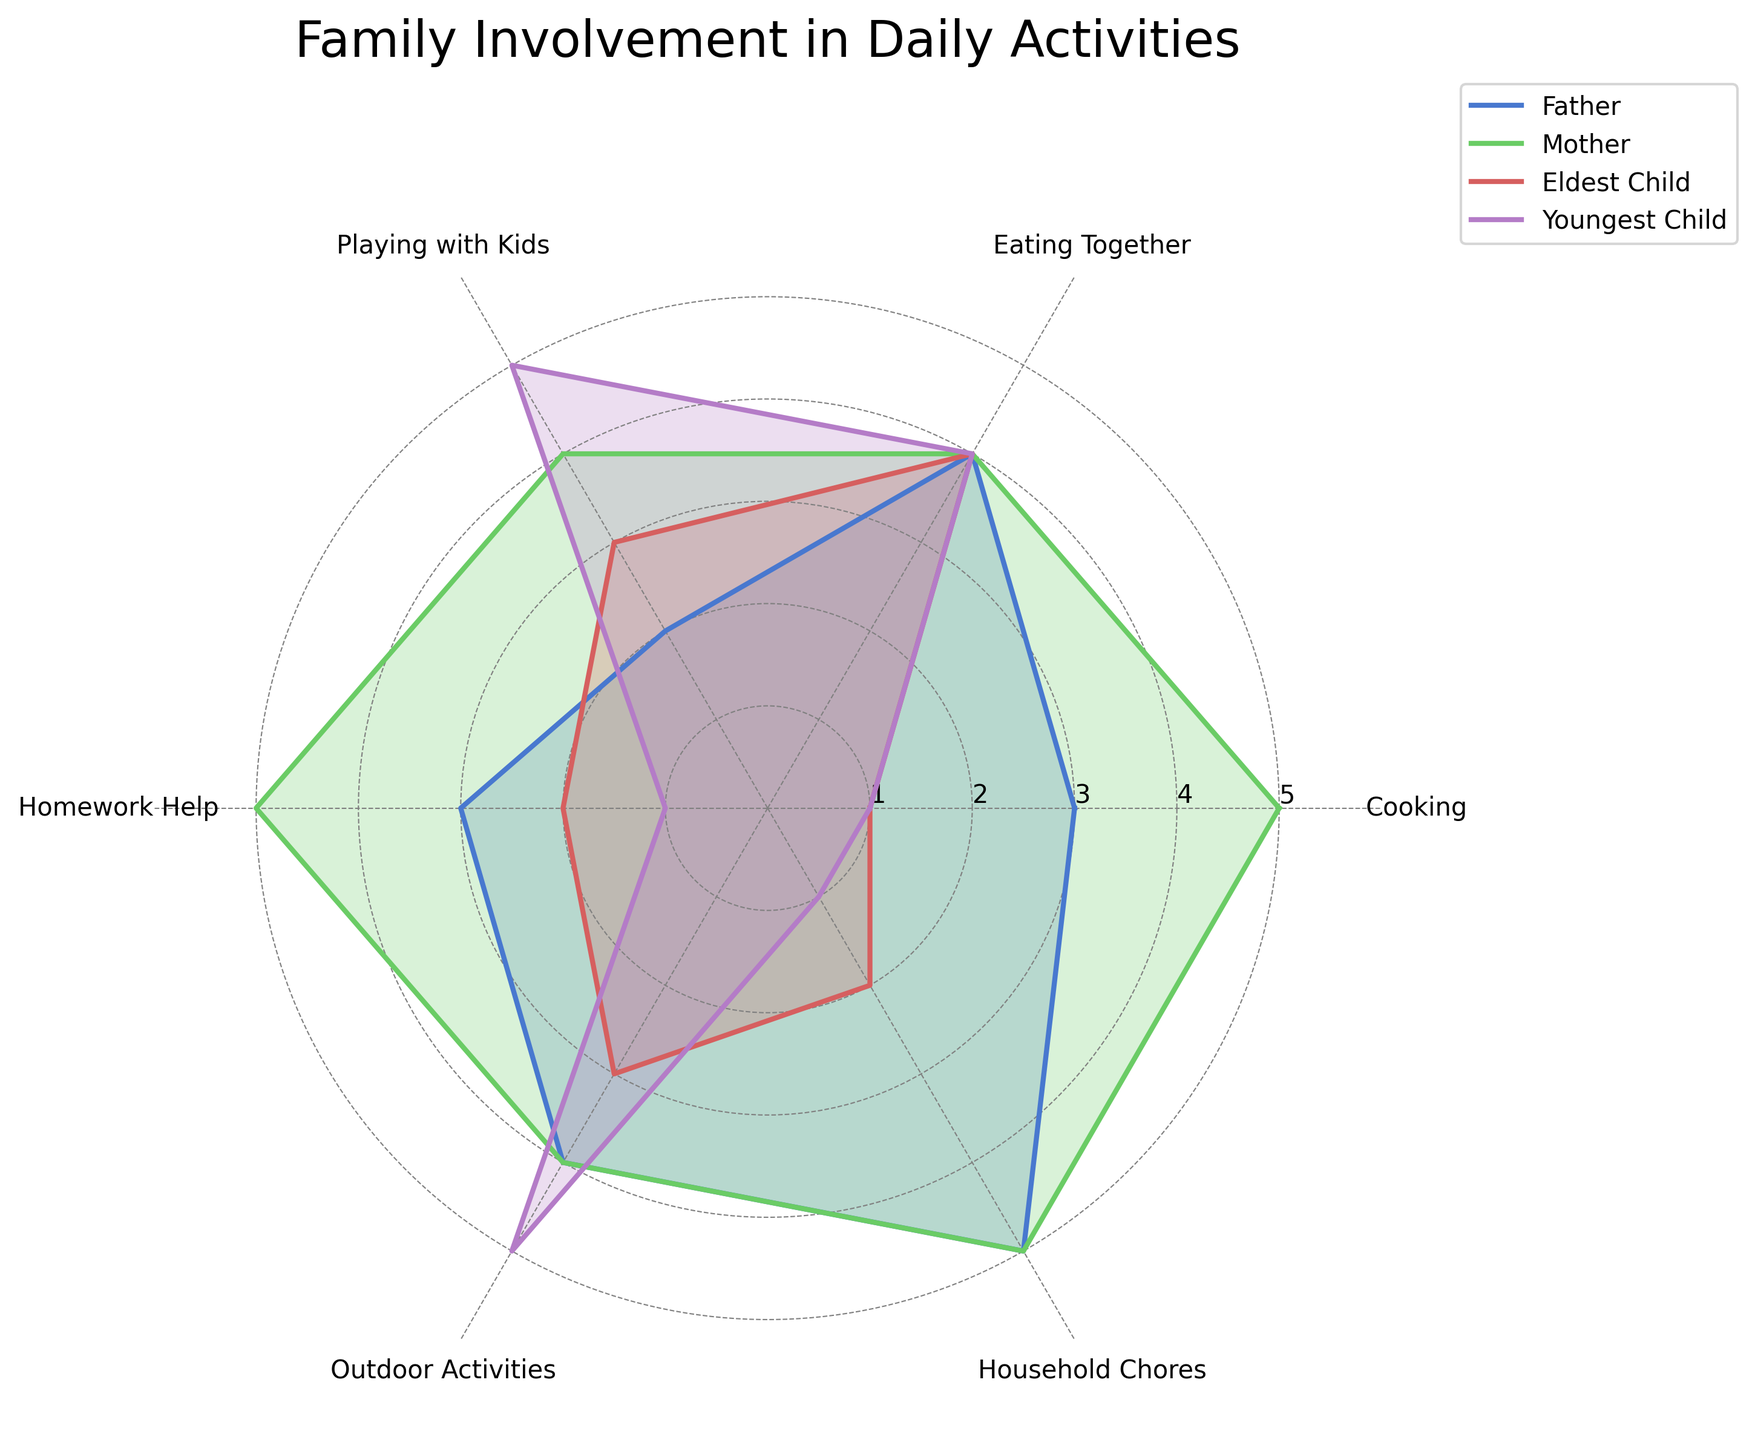What's the title of the chart? The title of the chart can be found at the top center of the figure. It describes the main topic visualized by the radar chart.
Answer: Family Involvement in Daily Activities Which family member has the highest involvement in 'Cooking'? By referring to the 'Cooking' axis on the radar chart, the length of the line for each family member in this category can be examined.
Answer: Mother What is the difference in 'Outdoor Activities' involvement between the Father and the Youngest Child? To find the difference, identify the values for both the Father and the Youngest Child for 'Outdoor Activities' and then subtract the Father's value from the Youngest Child's value. The Father's value is 4, and the Youngest Child's value is 5. So, 5 - 4 = 1
Answer: 1 Which activities have equal involvement from both the Eldest Child and the Youngest Child? Compare the values for each activity between the Eldest Child and the Youngest Child to find any matching values. Both have a value of 4 for 'Eating Together'.
Answer: Eating Together Who has the least involvement in 'Household Chores'? Look at the values for 'Household Chores' for each family member. The family member with the smallest value has the least involvement. The Eldest Child has a value of 2, and the Youngest Child has a value of 1.
Answer: Youngest Child What is the average involvement in 'Eating Together' across all family members? To find the average, sum up the 'Eating Together' values for all family members (Father: 4, Mother: 4, Eldest Child: 4, Youngest Child: 4). The total is 16, and there are 4 family members. So, 16 / 4 = 4
Answer: 4 How many activities have the Father and Mother participating equally? Compare the values for each activity between the Father and the Mother. They have equal values in 'Eating Together' and 'Outdoor Activities'.
Answer: 2 Which family member has the least variability in involvement across different activities? Look at the range or standard deviation of the values for each family member. The Mother has the values 5, 4, 4, 5, 4, 5, which vary the least compared to others.
Answer: Mother For 'Homework Help', how much more involved is the Mother compared to the other family members? Determine the value for 'Homework Help' for the Mother, which is 5, and compare it to the values for other members: Father (3), Eldest Child (2), Youngest Child (1). The differences are 5 - 3 = 2, 5 - 2 = 3, and 5 - 1 = 4.
Answer: 2, 3, and 4 